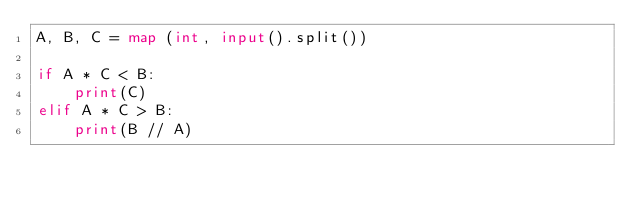Convert code to text. <code><loc_0><loc_0><loc_500><loc_500><_Python_>A, B, C = map (int, input().split())

if A * C < B:
    print(C)
elif A * C > B:
    print(B // A)

</code> 